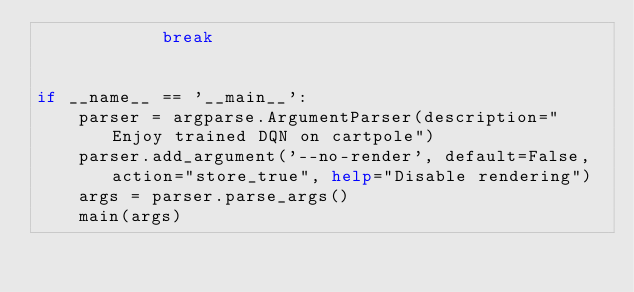Convert code to text. <code><loc_0><loc_0><loc_500><loc_500><_Python_>            break


if __name__ == '__main__':
    parser = argparse.ArgumentParser(description="Enjoy trained DQN on cartpole")
    parser.add_argument('--no-render', default=False, action="store_true", help="Disable rendering")
    args = parser.parse_args()
    main(args)
</code> 